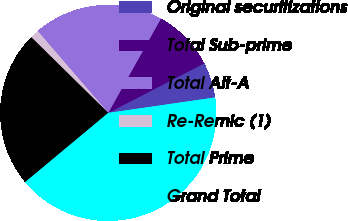Convert chart. <chart><loc_0><loc_0><loc_500><loc_500><pie_chart><fcel>Original securitizations<fcel>Total Sub-prime<fcel>Total Alt-A<fcel>Re-Remic (1)<fcel>Total Prime<fcel>Grand Total<nl><fcel>5.3%<fcel>9.3%<fcel>19.43%<fcel>1.31%<fcel>23.42%<fcel>41.23%<nl></chart> 